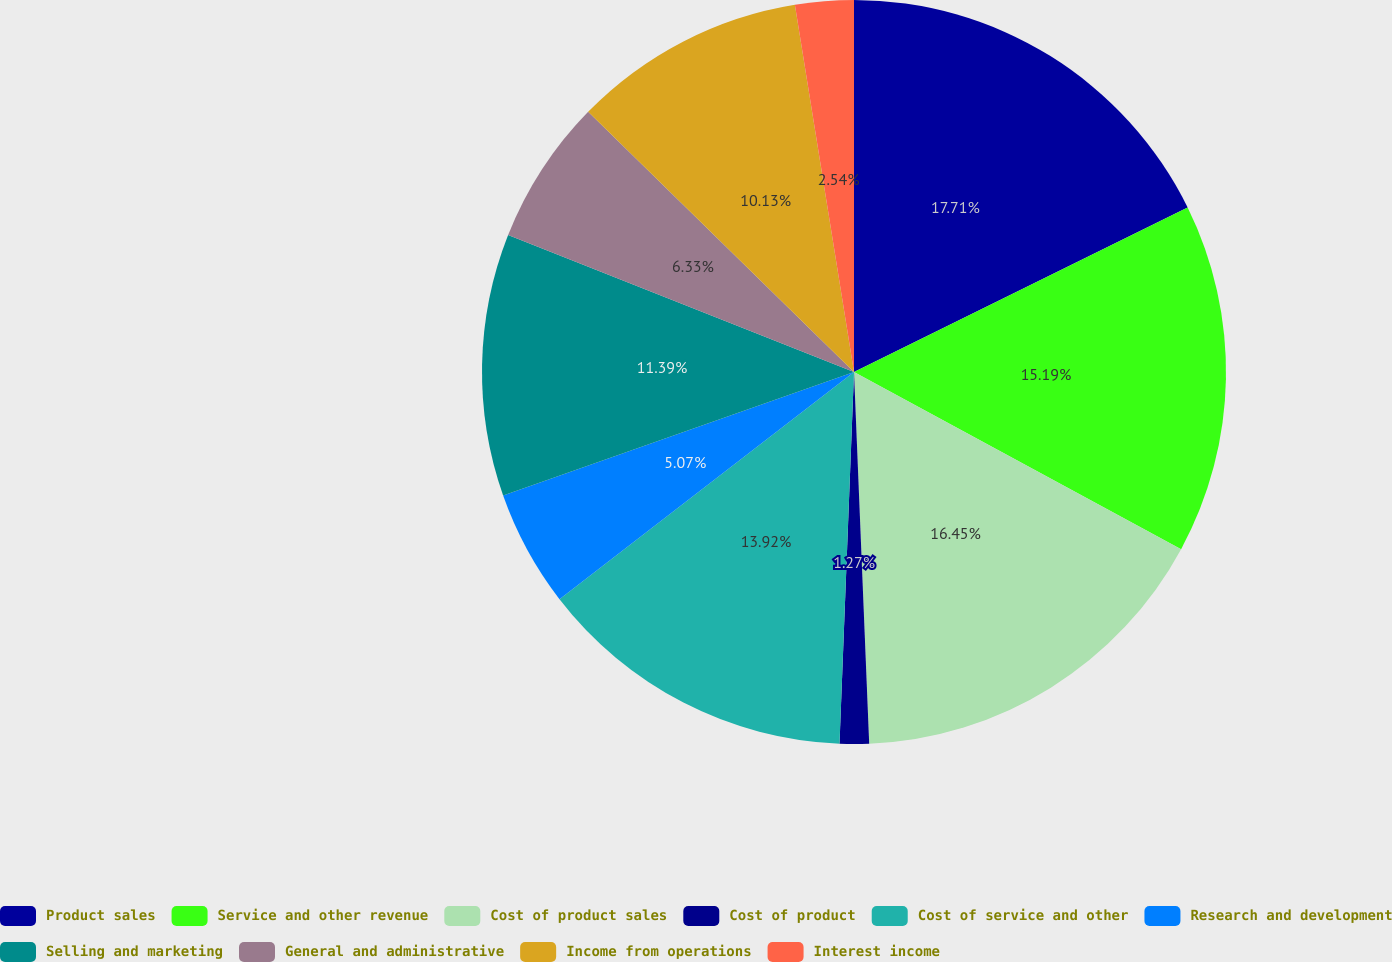<chart> <loc_0><loc_0><loc_500><loc_500><pie_chart><fcel>Product sales<fcel>Service and other revenue<fcel>Cost of product sales<fcel>Cost of product<fcel>Cost of service and other<fcel>Research and development<fcel>Selling and marketing<fcel>General and administrative<fcel>Income from operations<fcel>Interest income<nl><fcel>17.71%<fcel>15.19%<fcel>16.45%<fcel>1.27%<fcel>13.92%<fcel>5.07%<fcel>11.39%<fcel>6.33%<fcel>10.13%<fcel>2.54%<nl></chart> 